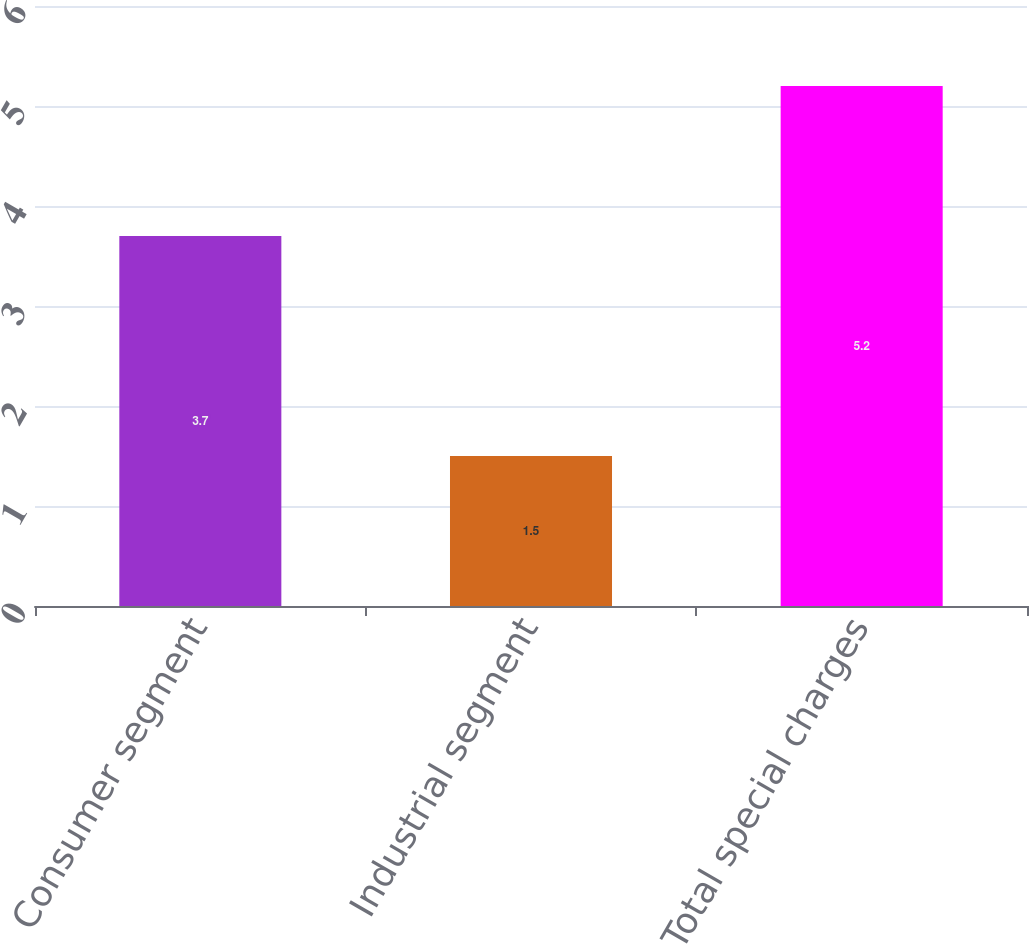<chart> <loc_0><loc_0><loc_500><loc_500><bar_chart><fcel>Consumer segment<fcel>Industrial segment<fcel>Total special charges<nl><fcel>3.7<fcel>1.5<fcel>5.2<nl></chart> 